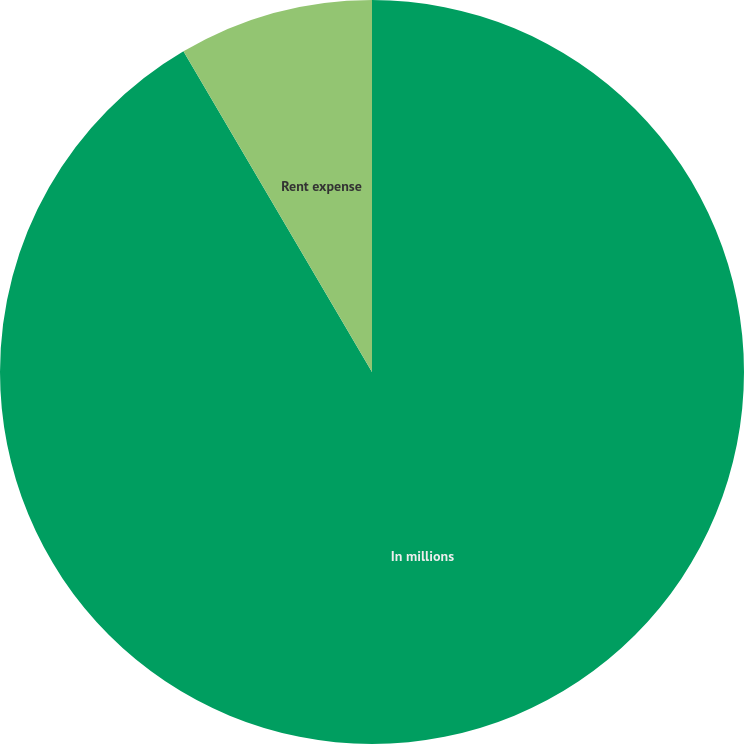<chart> <loc_0><loc_0><loc_500><loc_500><pie_chart><fcel>In millions<fcel>Rent expense<nl><fcel>91.54%<fcel>8.46%<nl></chart> 